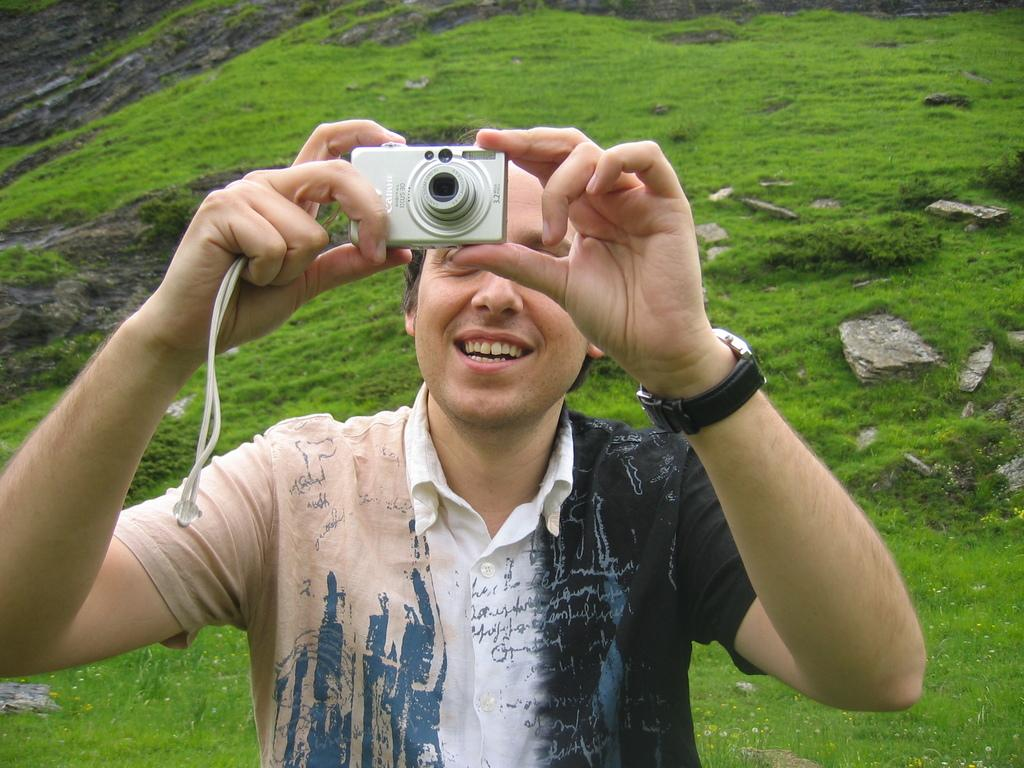Who is present in the image? There is a man in the image. What is the man holding in the image? The man is holding a camera. What can be seen in the background of the image? There is grass in the background of the image. What type of key is the man using to unlock the bedroom door in the image? There is no bedroom door or key present in the image; it only features a man holding a camera with grass in the background. 